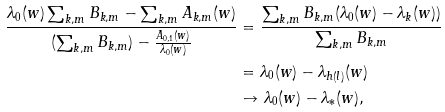Convert formula to latex. <formula><loc_0><loc_0><loc_500><loc_500>\frac { \lambda _ { 0 } ( w ) \sum _ { k , m } B _ { k , m } - \sum _ { k , m } A _ { k , m } ( w ) } { ( \sum _ { k , m } B _ { k , m } ) - \frac { A _ { 0 , 1 } ( w ) } { \lambda _ { 0 } ( w ) } } & = \frac { \sum _ { k , m } B _ { k , m } ( \lambda _ { 0 } ( w ) - \lambda _ { k } ( w ) ) } { \sum _ { k , m } B _ { k , m } } \\ & = \lambda _ { 0 } ( w ) - \lambda _ { h ( l ) } ( w ) \\ & \to \lambda _ { 0 } ( w ) - \lambda _ { \ast } ( w ) ,</formula> 